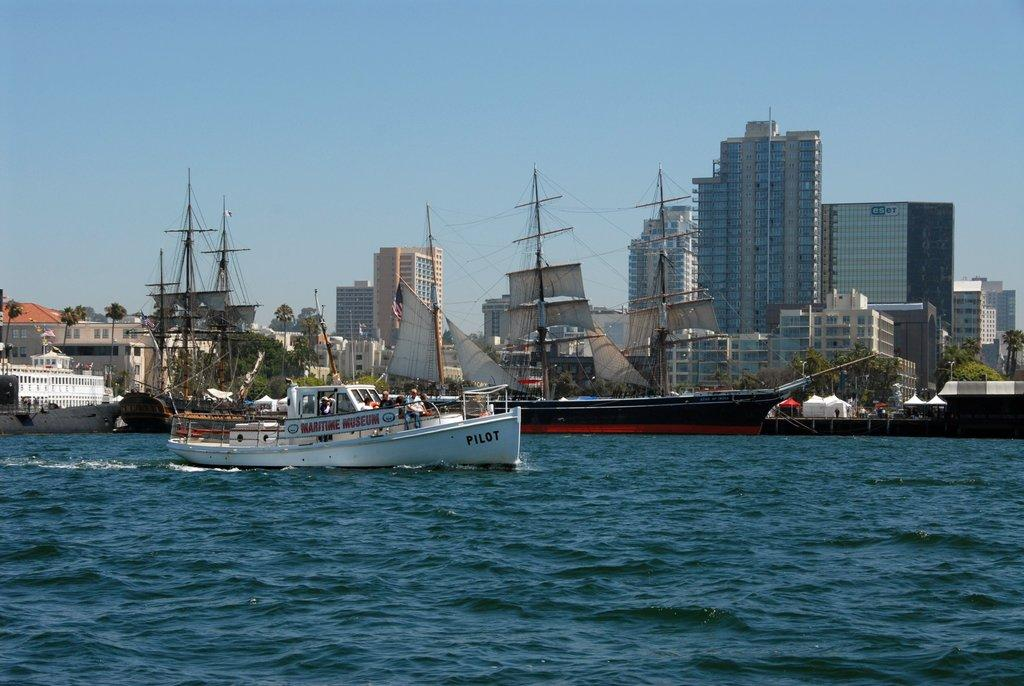What is in the water in the image? There are ships in the water in the image. Are there any people on the ships? Yes, there are people on one of the ships. What can be seen in the background of the image? There are buildings, trees, tents, and other objects in the background. What is visible in the sky in the image? The sky is visible in the background of the image. What type of plot is being used by the people on the ship to catch fish in the image? There is no indication in the image that the people on the ship are fishing or using a plot to catch fish. 